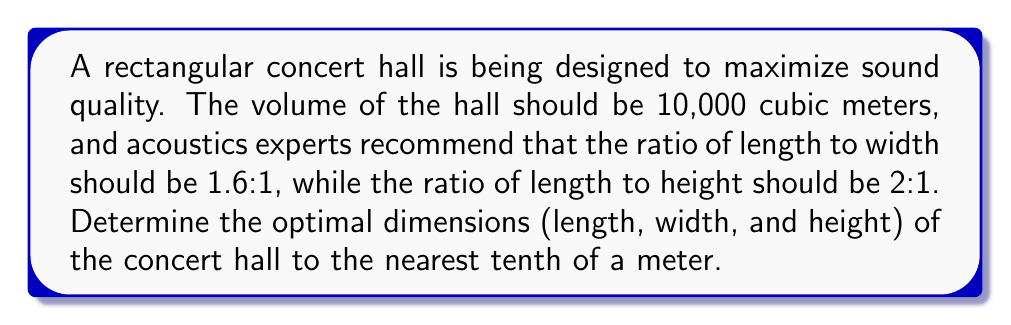Help me with this question. Let's approach this step-by-step:

1) Let $l$ be the length, $w$ be the width, and $h$ be the height of the hall.

2) Given the volume constraint:
   $$l \cdot w \cdot h = 10,000 \text{ m}^3$$

3) From the ratios provided:
   $$\frac{l}{w} = 1.6 \text{ and } \frac{l}{h} = 2$$

4) We can express $w$ and $h$ in terms of $l$:
   $$w = \frac{l}{1.6} \text{ and } h = \frac{l}{2}$$

5) Substituting these into the volume equation:
   $$l \cdot \frac{l}{1.6} \cdot \frac{l}{2} = 10,000$$

6) Simplifying:
   $$\frac{l^3}{3.2} = 10,000$$

7) Solving for $l$:
   $$l^3 = 32,000$$
   $$l = \sqrt[3]{32,000} \approx 31.7 \text{ m}$$

8) Now we can calculate $w$ and $h$:
   $$w = \frac{31.7}{1.6} \approx 19.8 \text{ m}$$
   $$h = \frac{31.7}{2} \approx 15.9 \text{ m}$$

9) Rounding to the nearest tenth:
   $l = 31.7 \text{ m}$, $w = 19.8 \text{ m}$, $h = 15.9 \text{ m}$

10) Verifying the volume:
    $$31.7 \cdot 19.8 \cdot 15.9 \approx 10,000 \text{ m}^3$$
Answer: Length: 31.7 m, Width: 19.8 m, Height: 15.9 m 